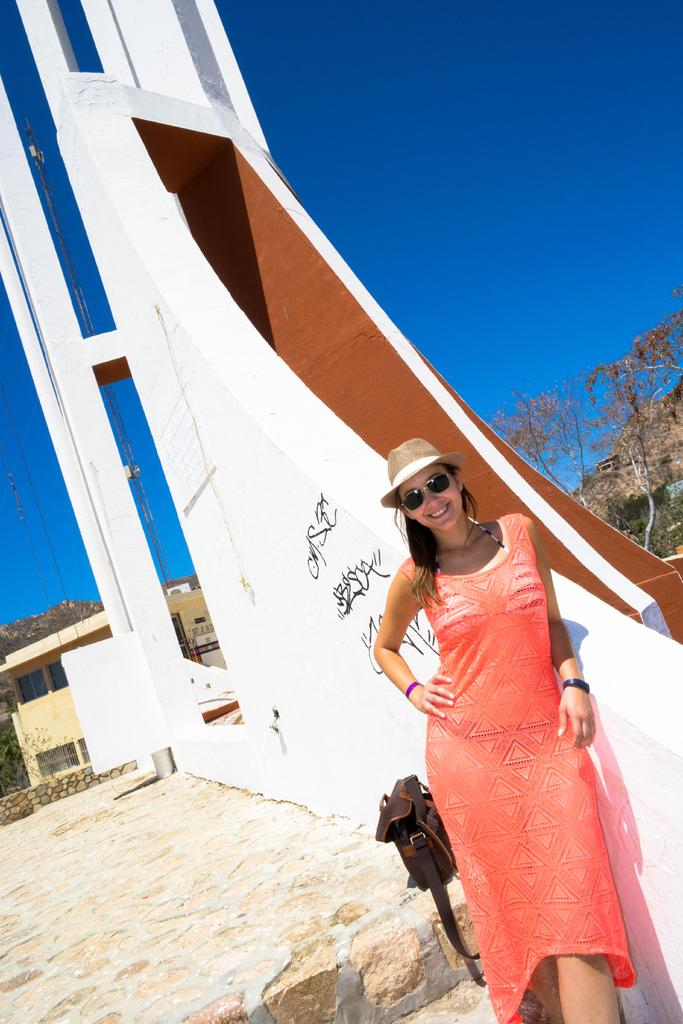Who is the main subject in the image? There is a woman standing in the front of the image. What is the woman doing in the image? The woman is smiling. What can be seen in the background of the image? There is a wall, a house, and trees in the background of the image. How many fairies are flying around the woman in the image? There are no fairies present in the image. What type of account does the woman have with the house in the background? There is no information about any accounts in the image. 